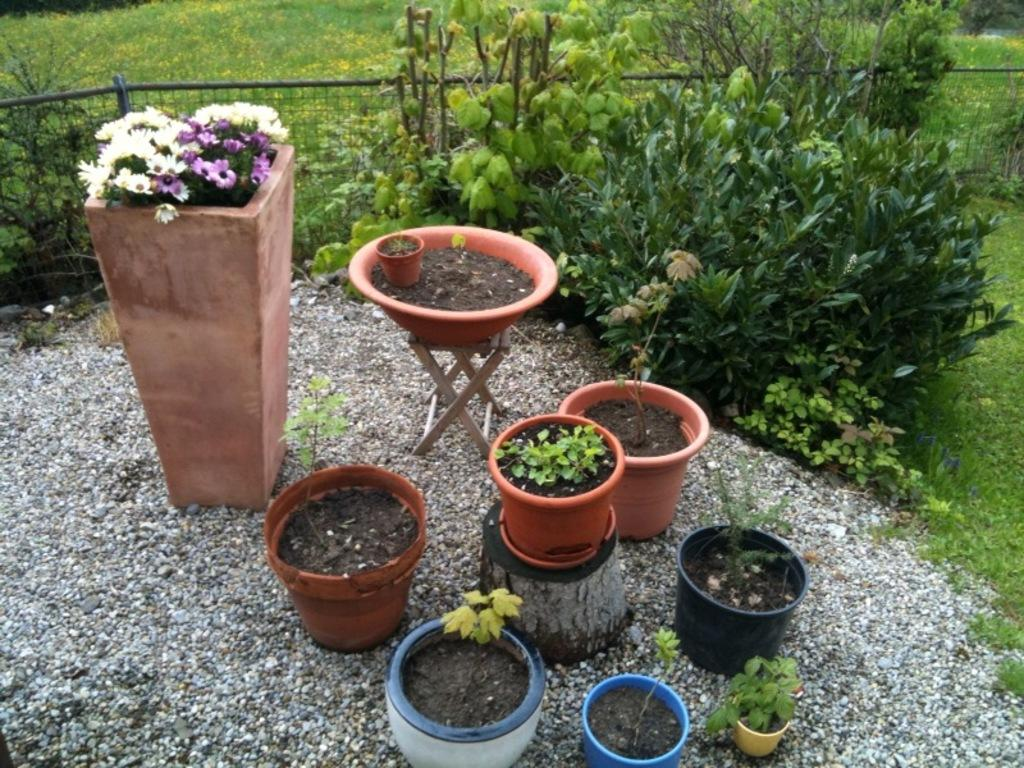What type of living organisms can be seen in the image? Plants, flowers, and grass are visible in the image. What objects are present in the image that might be used to hold or contain the plants? There are pots in the image that might be used to hold or contain the plants. What type of vegetation is visible in the image? Grass is visible in the image. What architectural feature can be seen in the image? There is a fence in the image. What type of punishment is being administered to the bead in the image? There is no bead present in the image, and therefore no such punishment can be observed. 